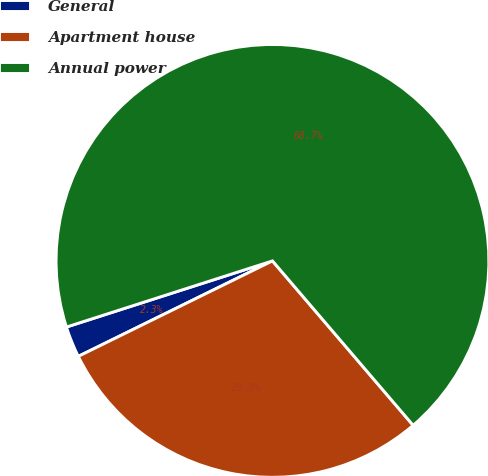<chart> <loc_0><loc_0><loc_500><loc_500><pie_chart><fcel>General<fcel>Apartment house<fcel>Annual power<nl><fcel>2.33%<fcel>28.99%<fcel>68.68%<nl></chart> 